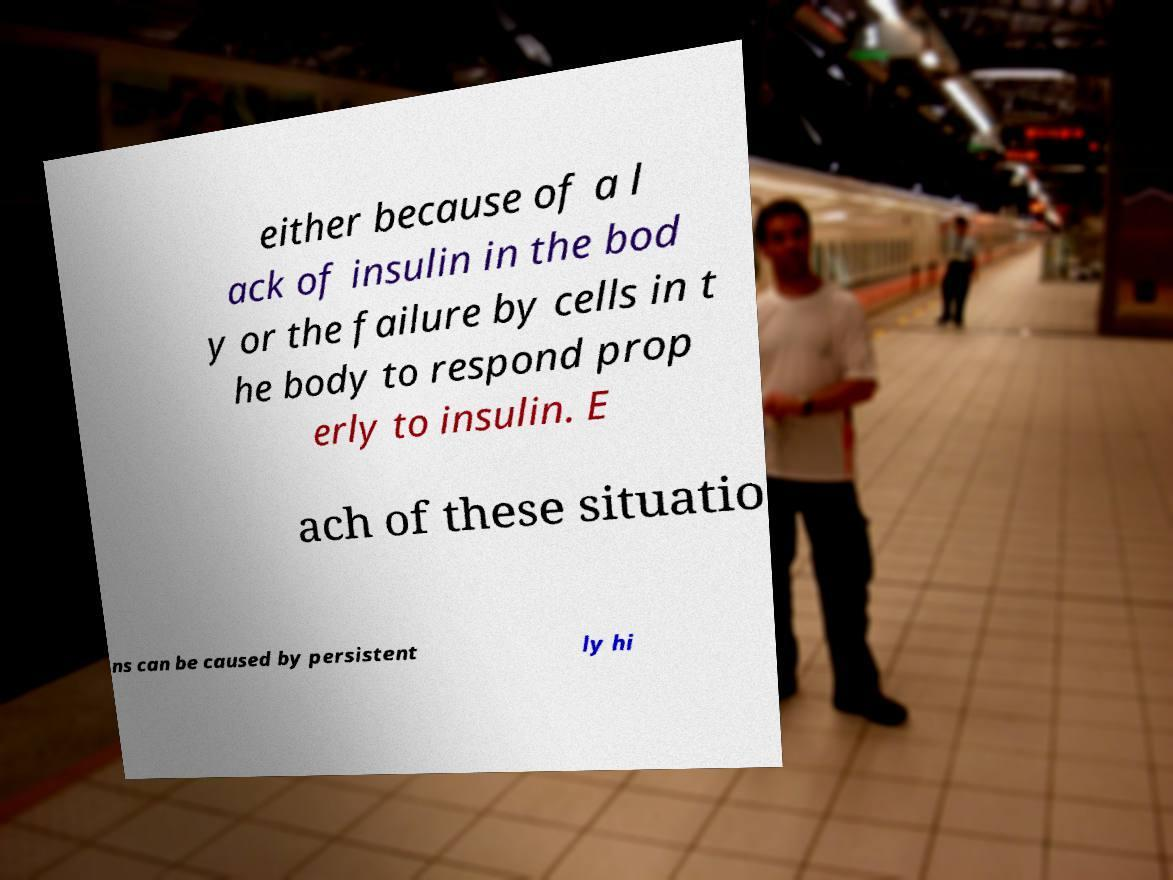I need the written content from this picture converted into text. Can you do that? either because of a l ack of insulin in the bod y or the failure by cells in t he body to respond prop erly to insulin. E ach of these situatio ns can be caused by persistent ly hi 